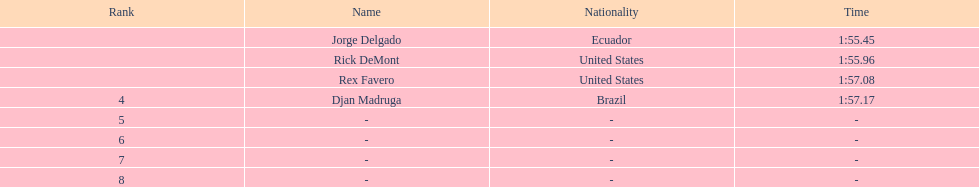Who was the last finisher from the us? Rex Favero. 